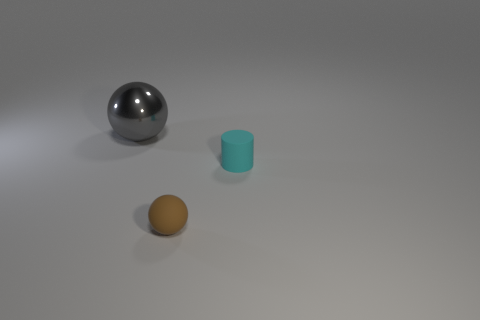Is there any other thing that has the same material as the big gray thing?
Ensure brevity in your answer.  No. What color is the sphere that is in front of the gray metallic object?
Your answer should be compact. Brown. Are there more small cyan matte cylinders on the right side of the brown matte object than large metal balls?
Your response must be concise. No. The large sphere has what color?
Provide a succinct answer. Gray. What shape is the matte object that is behind the sphere to the right of the sphere behind the tiny brown matte thing?
Your answer should be very brief. Cylinder. What is the material of the object that is both behind the small matte sphere and in front of the gray sphere?
Keep it short and to the point. Rubber. What shape is the rubber object that is left of the small object on the right side of the brown matte sphere?
Give a very brief answer. Sphere. Is there anything else of the same color as the cylinder?
Ensure brevity in your answer.  No. Does the gray shiny sphere have the same size as the ball that is to the right of the shiny ball?
Your response must be concise. No. How many large objects are brown spheres or rubber things?
Provide a succinct answer. 0. 